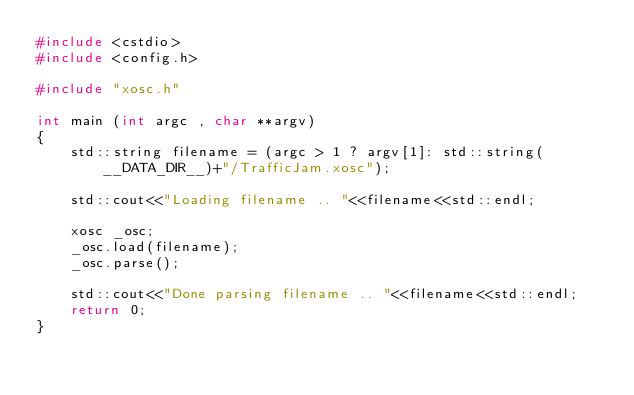<code> <loc_0><loc_0><loc_500><loc_500><_C++_>#include <cstdio>
#include <config.h>

#include "xosc.h"

int main (int argc , char **argv)
{
    std::string filename = (argc > 1 ? argv[1]: std::string(__DATA_DIR__)+"/TrafficJam.xosc");

    std::cout<<"Loading filename .. "<<filename<<std::endl;
    
    xosc _osc;
    _osc.load(filename);
    _osc.parse();

    std::cout<<"Done parsing filename .. "<<filename<<std::endl;
    return 0;
}
</code> 